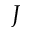<formula> <loc_0><loc_0><loc_500><loc_500>J</formula> 